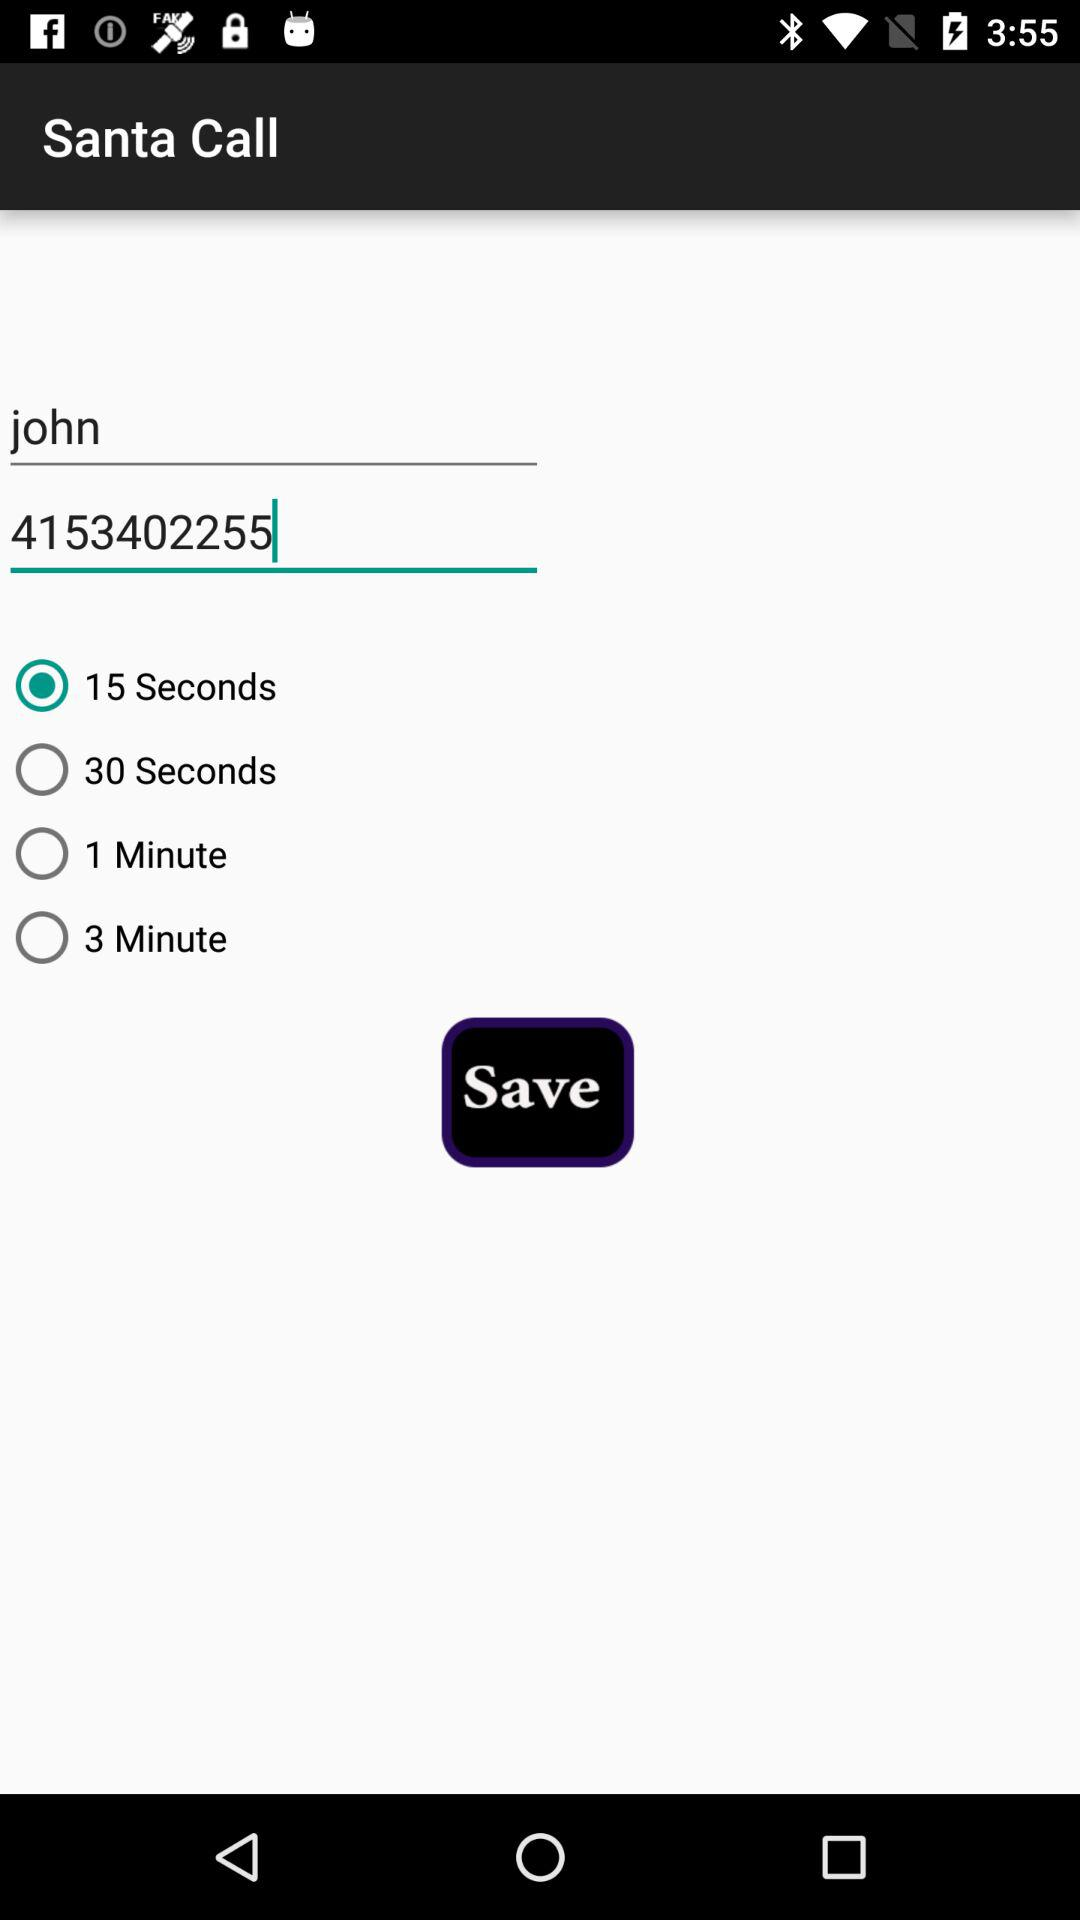What is the selected time? The selected time is 15 seconds. 